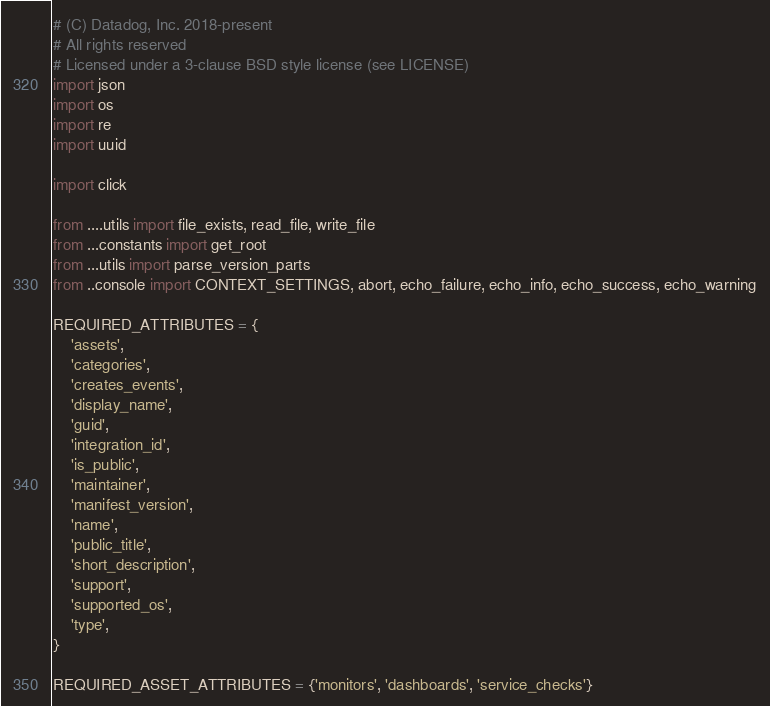Convert code to text. <code><loc_0><loc_0><loc_500><loc_500><_Python_># (C) Datadog, Inc. 2018-present
# All rights reserved
# Licensed under a 3-clause BSD style license (see LICENSE)
import json
import os
import re
import uuid

import click

from ....utils import file_exists, read_file, write_file
from ...constants import get_root
from ...utils import parse_version_parts
from ..console import CONTEXT_SETTINGS, abort, echo_failure, echo_info, echo_success, echo_warning

REQUIRED_ATTRIBUTES = {
    'assets',
    'categories',
    'creates_events',
    'display_name',
    'guid',
    'integration_id',
    'is_public',
    'maintainer',
    'manifest_version',
    'name',
    'public_title',
    'short_description',
    'support',
    'supported_os',
    'type',
}

REQUIRED_ASSET_ATTRIBUTES = {'monitors', 'dashboards', 'service_checks'}
</code> 